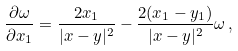Convert formula to latex. <formula><loc_0><loc_0><loc_500><loc_500>\frac { \partial \omega } { \partial x _ { 1 } } = \frac { 2 x _ { 1 } } { | x - y | ^ { 2 } } - \frac { 2 ( x _ { 1 } - y _ { 1 } ) } { | x - y | ^ { 2 } } \omega \, ,</formula> 